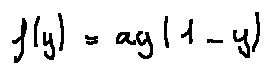Convert formula to latex. <formula><loc_0><loc_0><loc_500><loc_500>f ( y ) = a y ( 1 - y )</formula> 